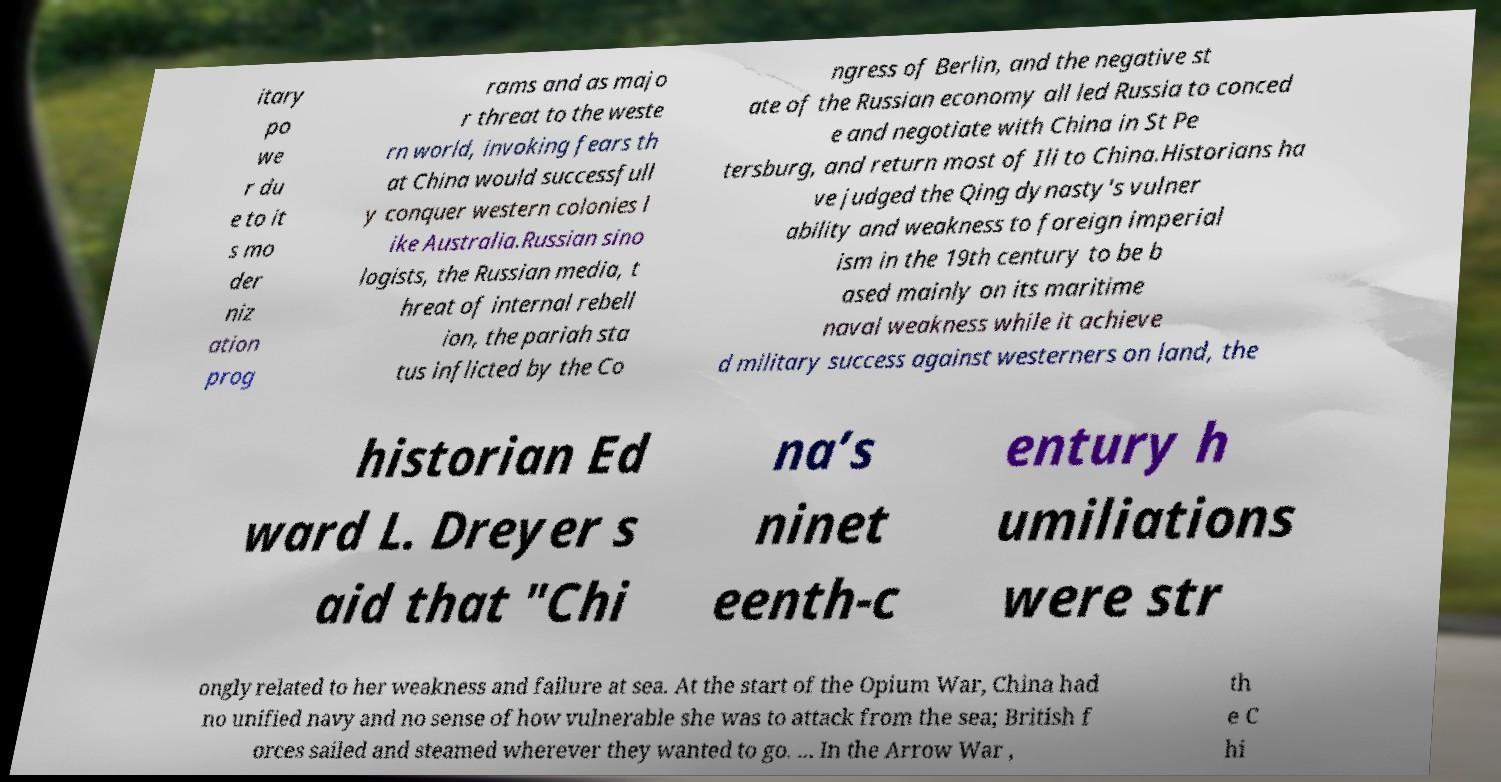What messages or text are displayed in this image? I need them in a readable, typed format. itary po we r du e to it s mo der niz ation prog rams and as majo r threat to the weste rn world, invoking fears th at China would successfull y conquer western colonies l ike Australia.Russian sino logists, the Russian media, t hreat of internal rebell ion, the pariah sta tus inflicted by the Co ngress of Berlin, and the negative st ate of the Russian economy all led Russia to conced e and negotiate with China in St Pe tersburg, and return most of Ili to China.Historians ha ve judged the Qing dynasty's vulner ability and weakness to foreign imperial ism in the 19th century to be b ased mainly on its maritime naval weakness while it achieve d military success against westerners on land, the historian Ed ward L. Dreyer s aid that "Chi na’s ninet eenth-c entury h umiliations were str ongly related to her weakness and failure at sea. At the start of the Opium War, China had no unified navy and no sense of how vulnerable she was to attack from the sea; British f orces sailed and steamed wherever they wanted to go. ... In the Arrow War , th e C hi 